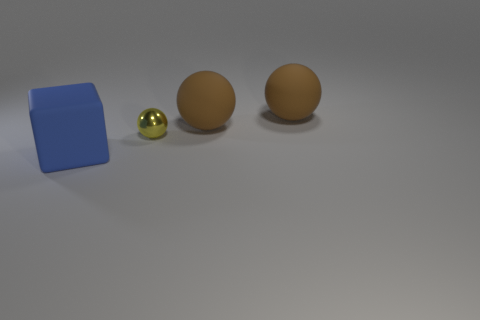There is a metallic sphere; does it have the same color as the big object to the left of the tiny yellow shiny sphere?
Provide a short and direct response. No. There is a rubber thing that is on the left side of the small yellow metallic ball; does it have the same color as the tiny metallic object?
Provide a succinct answer. No. What number of objects are yellow metal spheres or yellow things that are behind the blue cube?
Give a very brief answer. 1. What is the large thing that is left of the metallic sphere made of?
Provide a succinct answer. Rubber. Does the yellow metallic thing have the same shape as the large object on the left side of the tiny yellow metal sphere?
Your answer should be compact. No. There is a blue cube; are there any rubber blocks right of it?
Your answer should be compact. No. There is a yellow metallic thing; is it the same size as the matte thing that is in front of the small object?
Keep it short and to the point. No. Is there a thing that has the same color as the big block?
Ensure brevity in your answer.  No. Are there any big blue objects of the same shape as the small object?
Your response must be concise. No. What number of other small balls are made of the same material as the tiny ball?
Your response must be concise. 0. 